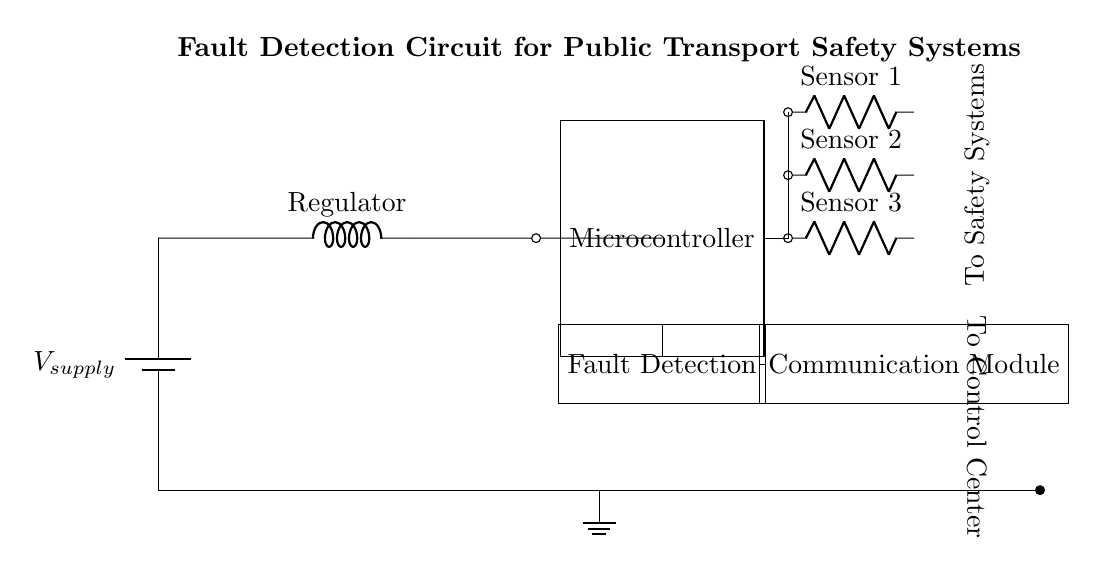What is the main power supply in this circuit? The circuit shows a battery labeled as V_supply, which indicates the primary power source.
Answer: V_supply How many sensors are connected to the microcontroller? There are three sensors connected to the microcontroller, each connected to a distinct node represented in the circuit.
Answer: Three What is the purpose of the fault detection component? The fault detection component is labeled as 'Fault Detection', signifying its role in monitoring and identifying faults in the system.
Answer: Monitoring faults Which component connects the fault detection circuit to the communication module? The circuit diagram shows a direct connection from the fault detection component to the communication module.
Answer: Direct connection What type of signals do the sensors likely produce? The signals from the sensors are most likely analog or digital signals, as they are commonly used in monitoring systems.
Answer: Analog or digital Why is it important to have a communication module in the fault detection circuit? The communication module enables the transmission of fault data to a control center, allowing for real-time monitoring and response.
Answer: Real-time monitoring What is the overall function of this entire circuit? The overall function is to monitor critical safety systems in public transport infrastructure and relay any detected faults.
Answer: Monitoring safety systems 